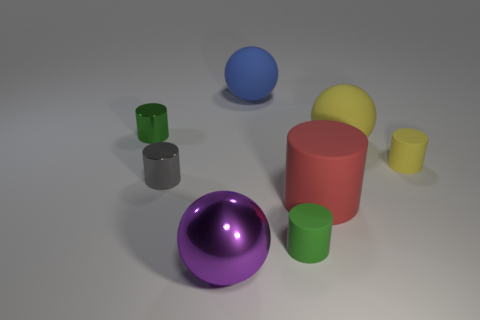How many green cylinders must be subtracted to get 1 green cylinders? 1 Subtract all gray cylinders. How many cylinders are left? 4 Subtract 2 cylinders. How many cylinders are left? 3 Subtract all tiny yellow rubber cylinders. How many cylinders are left? 4 Subtract all purple cylinders. Subtract all red cubes. How many cylinders are left? 5 Add 1 big shiny cylinders. How many objects exist? 9 Subtract all cylinders. How many objects are left? 3 Subtract all yellow matte cylinders. Subtract all yellow matte cylinders. How many objects are left? 6 Add 6 large purple objects. How many large purple objects are left? 7 Add 2 red cubes. How many red cubes exist? 2 